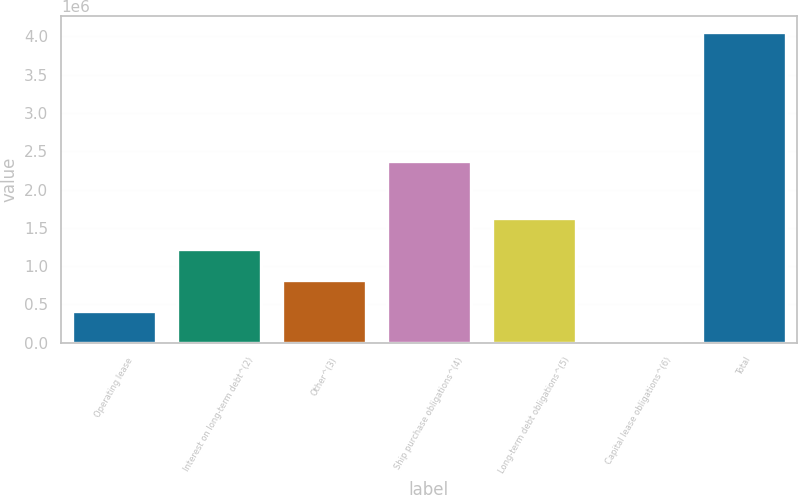Convert chart. <chart><loc_0><loc_0><loc_500><loc_500><bar_chart><fcel>Operating lease<fcel>Interest on long-term debt^(2)<fcel>Other^(3)<fcel>Ship purchase obligations^(4)<fcel>Long-term debt obligations^(5)<fcel>Capital lease obligations^(6)<fcel>Total<nl><fcel>409194<fcel>1.22063e+06<fcel>814911<fcel>2.36881e+06<fcel>1.62635e+06<fcel>3476<fcel>4.06065e+06<nl></chart> 